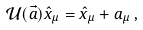Convert formula to latex. <formula><loc_0><loc_0><loc_500><loc_500>\mathcal { U } ( \vec { a } ) \hat { x } _ { \mu } = \hat { x } _ { \mu } + a _ { \mu } \, ,</formula> 